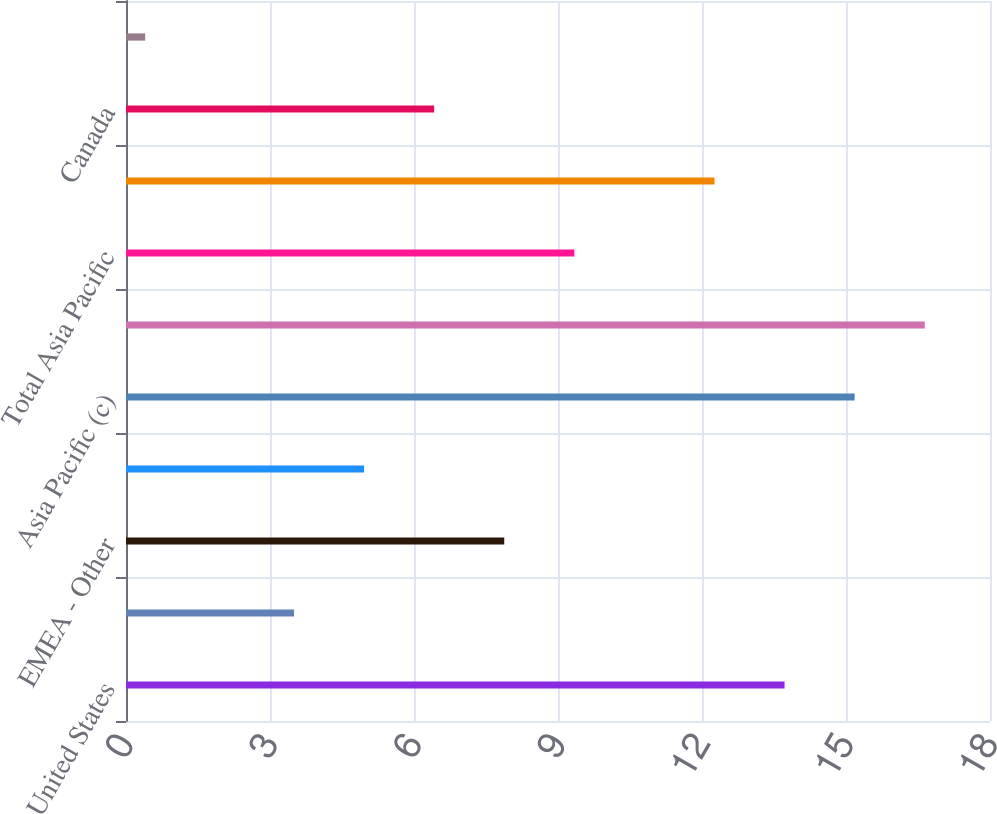Convert chart to OTSL. <chart><loc_0><loc_0><loc_500><loc_500><bar_chart><fcel>United States<fcel>Europe (b)<fcel>EMEA - Other<fcel>Total EMEA<fcel>Asia Pacific (c)<fcel>Asia Pacific - Other<fcel>Total Asia Pacific<fcel>Latin America<fcel>Canada<fcel>Total International Retail<nl><fcel>13.72<fcel>3.5<fcel>7.88<fcel>4.96<fcel>15.18<fcel>16.64<fcel>9.34<fcel>12.26<fcel>6.42<fcel>0.4<nl></chart> 